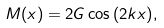Convert formula to latex. <formula><loc_0><loc_0><loc_500><loc_500>M ( x ) = 2 G \cos { ( 2 k x ) } ,</formula> 